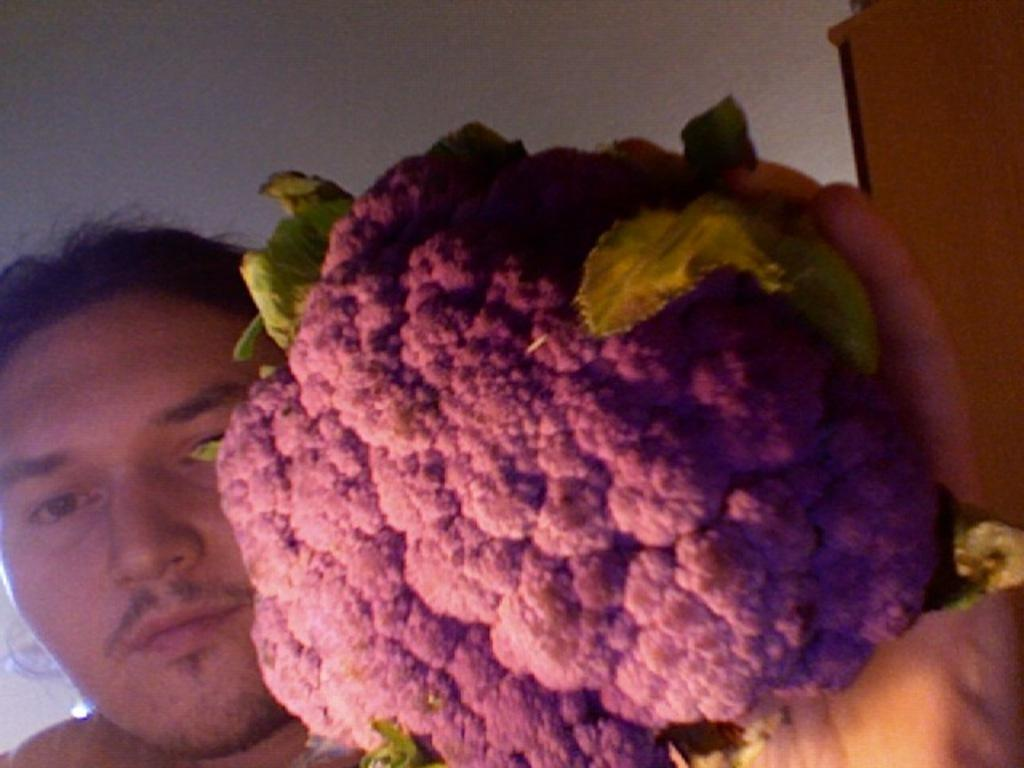Who is present in the image? There is a person in the image. What is the person holding? The person is holding a cauliflower. What is the person doing in the image? The person is looking at the picture. What can be seen on the right side of the image? There is a cupboard on the right side of the image. What is visible in the background of the image? There is a wall in the background of the image. How many legs can be seen on the pencil in the image? There is no pencil present in the image, so it is not possible to determine the number of legs on a pencil. 